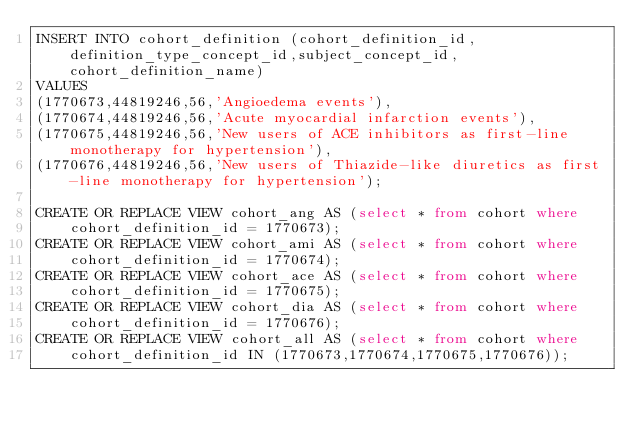<code> <loc_0><loc_0><loc_500><loc_500><_SQL_>INSERT INTO cohort_definition (cohort_definition_id,definition_type_concept_id,subject_concept_id,cohort_definition_name)
VALUES 
(1770673,44819246,56,'Angioedema events'),
(1770674,44819246,56,'Acute myocardial infarction events'),
(1770675,44819246,56,'New users of ACE inhibitors as first-line monotherapy for hypertension'),
(1770676,44819246,56,'New users of Thiazide-like diuretics as first-line monotherapy for hypertension');

CREATE OR REPLACE VIEW cohort_ang AS (select * from cohort where
    cohort_definition_id = 1770673);
CREATE OR REPLACE VIEW cohort_ami AS (select * from cohort where
    cohort_definition_id = 1770674);
CREATE OR REPLACE VIEW cohort_ace AS (select * from cohort where
    cohort_definition_id = 1770675);
CREATE OR REPLACE VIEW cohort_dia AS (select * from cohort where
    cohort_definition_id = 1770676);
CREATE OR REPLACE VIEW cohort_all AS (select * from cohort where
    cohort_definition_id IN (1770673,1770674,1770675,1770676));
</code> 